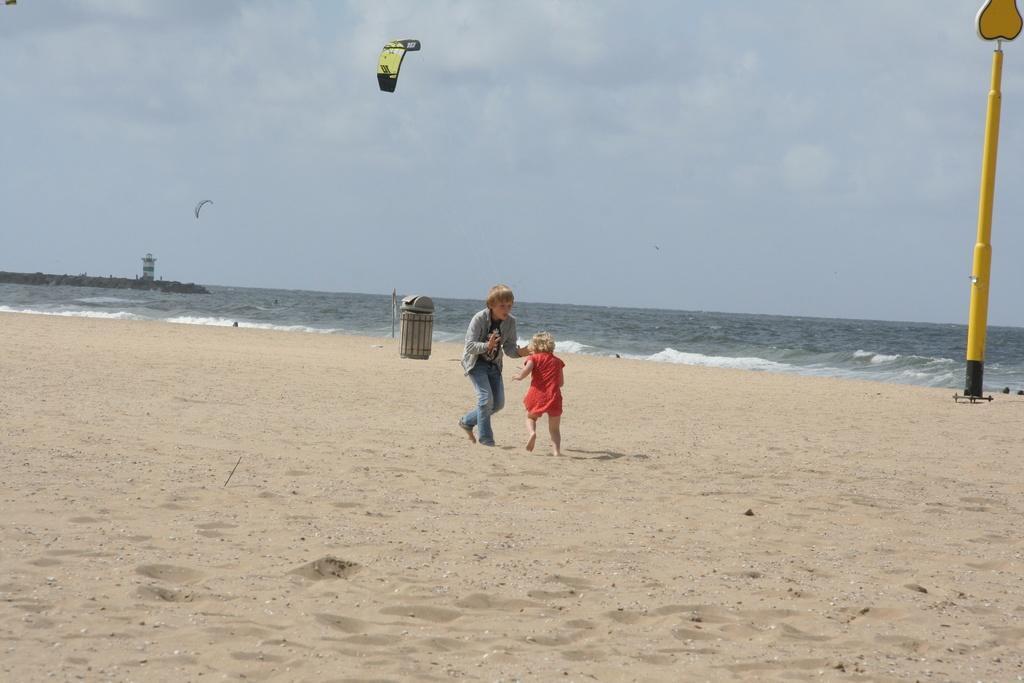Could you give a brief overview of what you see in this image? In this image there is a bin, children, sand, water, cloudy sky, paragliding, tower, pole, board and objects. 